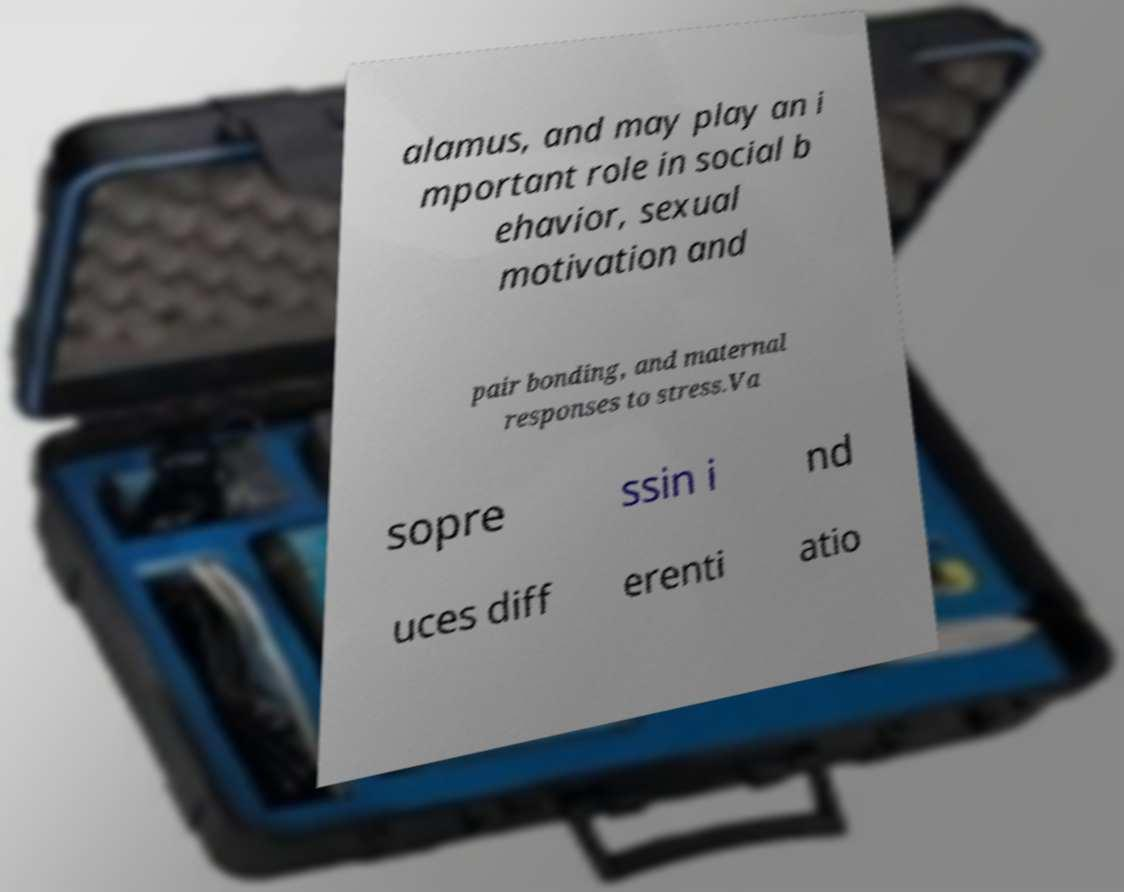I need the written content from this picture converted into text. Can you do that? alamus, and may play an i mportant role in social b ehavior, sexual motivation and pair bonding, and maternal responses to stress.Va sopre ssin i nd uces diff erenti atio 